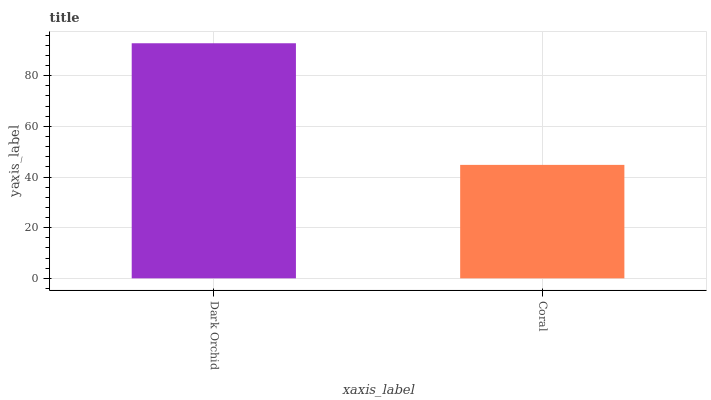Is Coral the minimum?
Answer yes or no. Yes. Is Dark Orchid the maximum?
Answer yes or no. Yes. Is Coral the maximum?
Answer yes or no. No. Is Dark Orchid greater than Coral?
Answer yes or no. Yes. Is Coral less than Dark Orchid?
Answer yes or no. Yes. Is Coral greater than Dark Orchid?
Answer yes or no. No. Is Dark Orchid less than Coral?
Answer yes or no. No. Is Dark Orchid the high median?
Answer yes or no. Yes. Is Coral the low median?
Answer yes or no. Yes. Is Coral the high median?
Answer yes or no. No. Is Dark Orchid the low median?
Answer yes or no. No. 